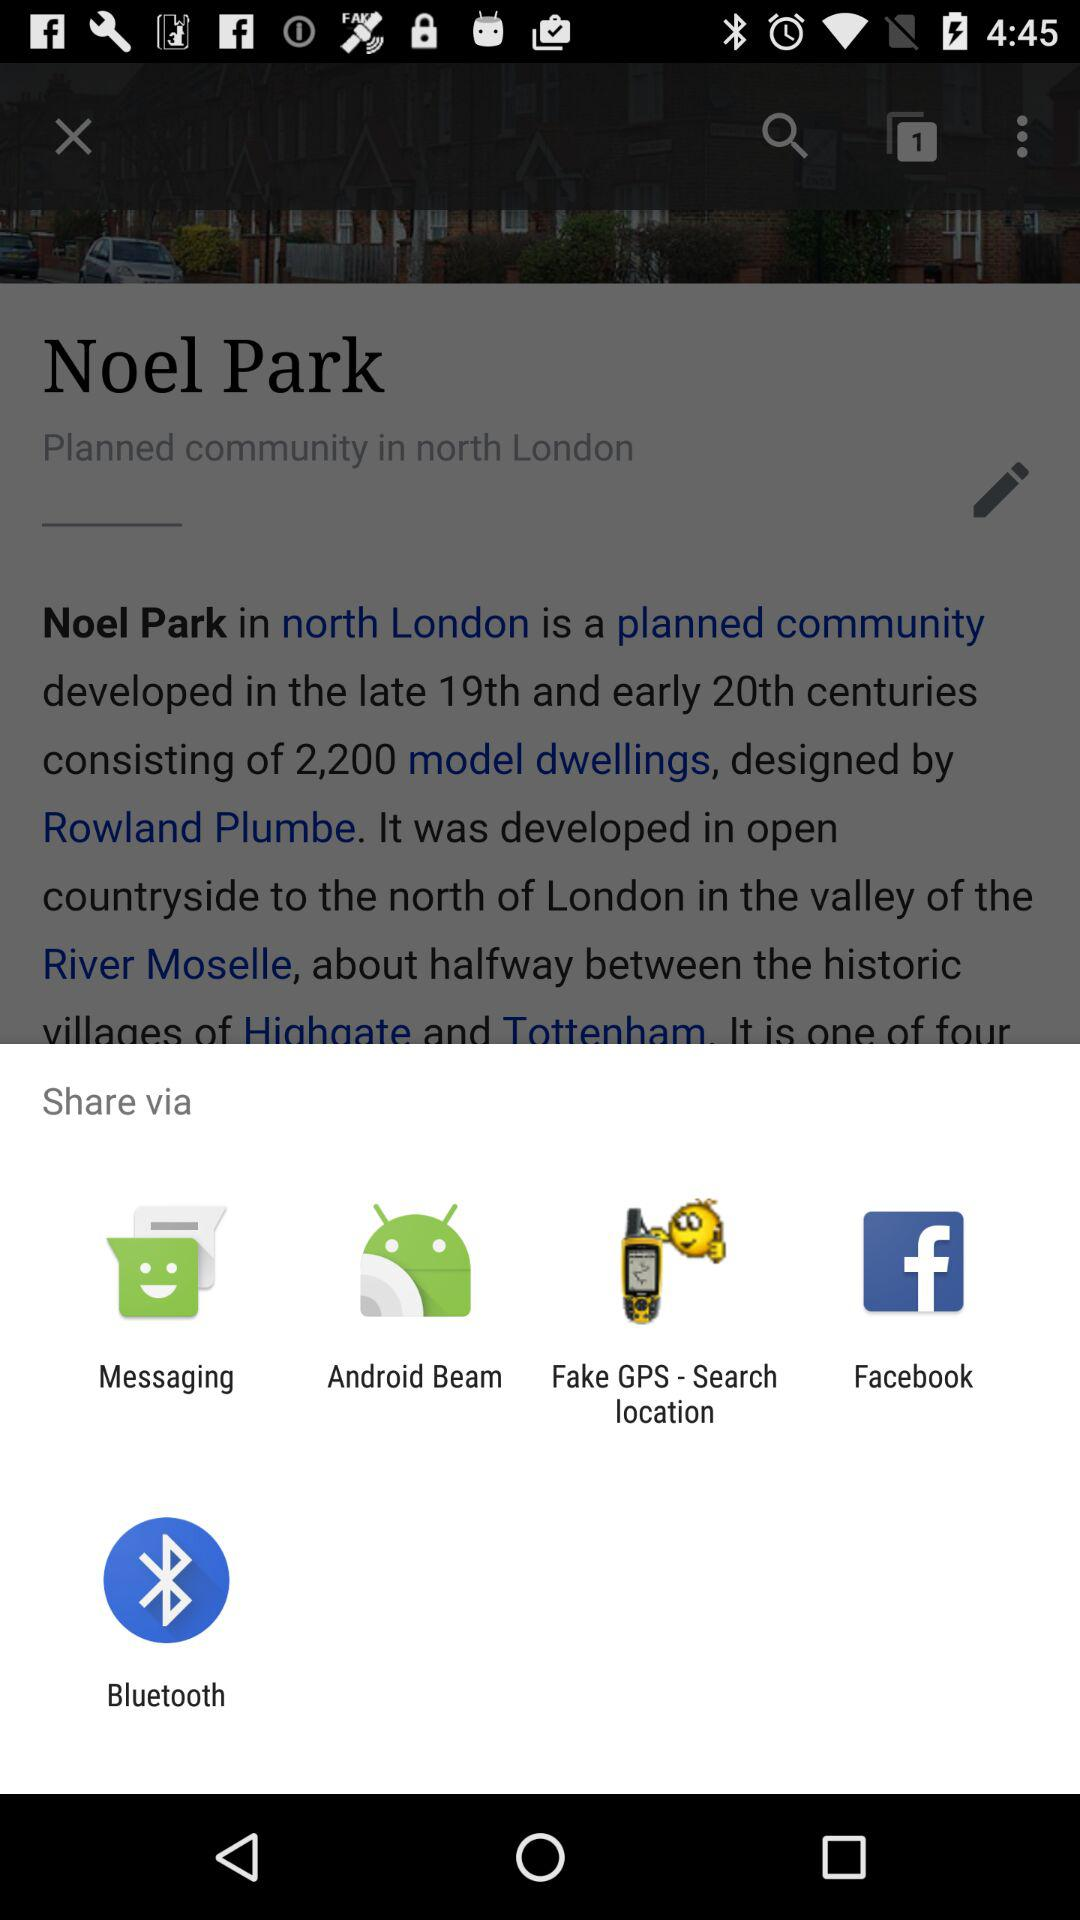Who designed Noel Park? Noel Park was designed by Rowland Plumbe. 